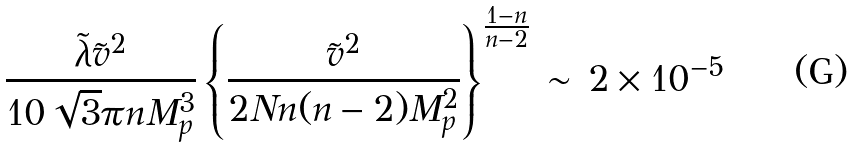<formula> <loc_0><loc_0><loc_500><loc_500>\frac { \tilde { \lambda } \tilde { v } ^ { 2 } } { 1 0 \sqrt { 3 } \pi n M _ { p } ^ { 3 } } \left \{ \frac { \tilde { v } ^ { 2 } } { 2 N n ( n - 2 ) M _ { p } ^ { 2 } } \right \} ^ { \frac { 1 - n } { n - 2 } } \, \sim \, 2 \times 1 0 ^ { - 5 }</formula> 